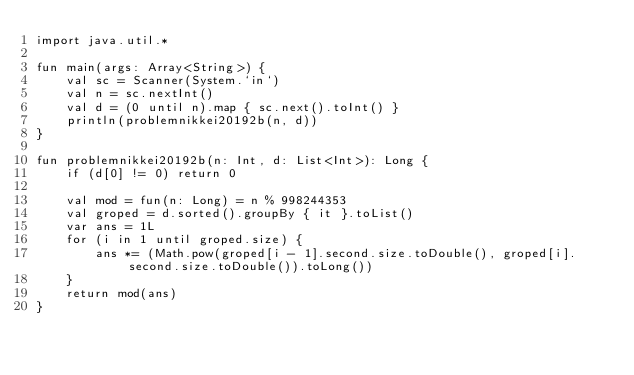Convert code to text. <code><loc_0><loc_0><loc_500><loc_500><_Kotlin_>import java.util.*

fun main(args: Array<String>) {
    val sc = Scanner(System.`in`)
    val n = sc.nextInt()
    val d = (0 until n).map { sc.next().toInt() }
    println(problemnikkei20192b(n, d))
}

fun problemnikkei20192b(n: Int, d: List<Int>): Long {
    if (d[0] != 0) return 0

    val mod = fun(n: Long) = n % 998244353
    val groped = d.sorted().groupBy { it }.toList()
    var ans = 1L
    for (i in 1 until groped.size) {
        ans *= (Math.pow(groped[i - 1].second.size.toDouble(), groped[i].second.size.toDouble()).toLong())
    }
    return mod(ans)
}</code> 